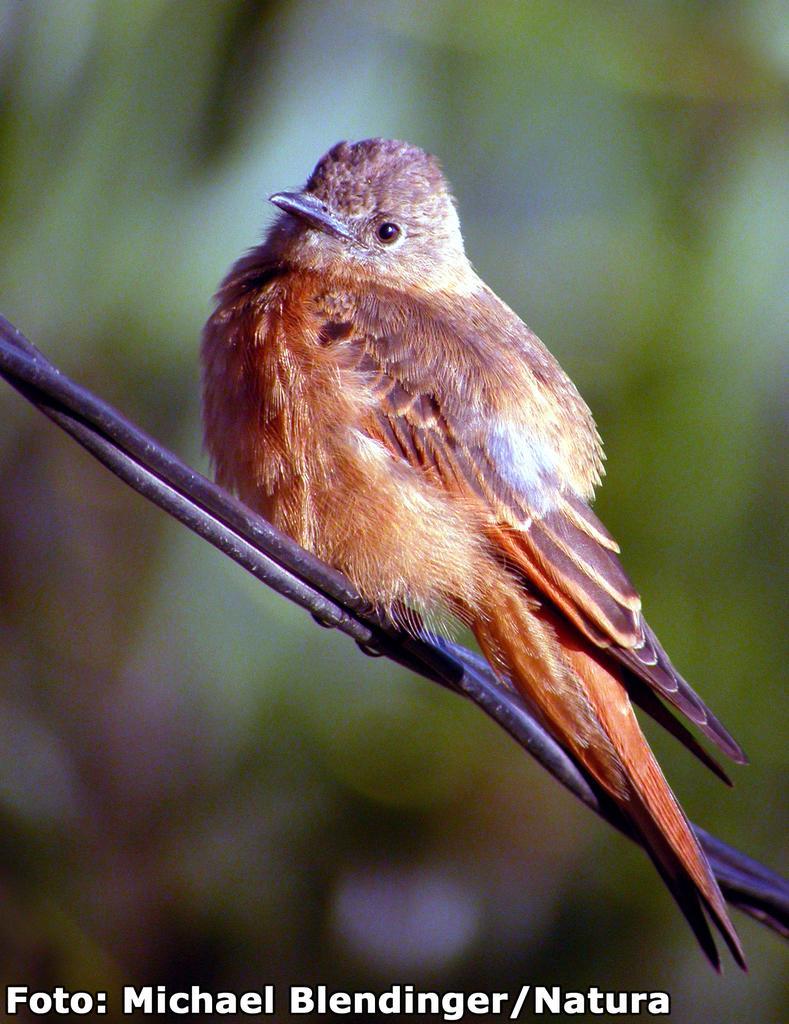Please provide a concise description of this image. In this image I can see the bird which is in brown color. It is on the wire. And there is a blurred background. I can also see the watermark in the image. 